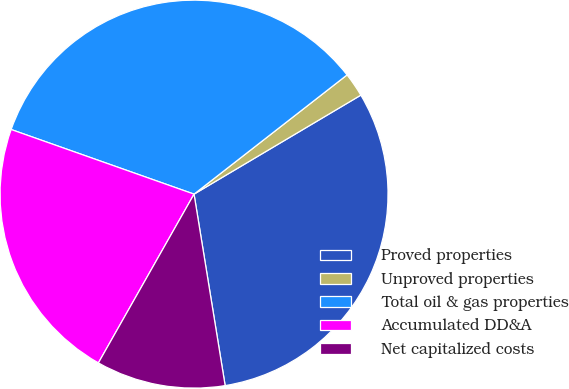Convert chart. <chart><loc_0><loc_0><loc_500><loc_500><pie_chart><fcel>Proved properties<fcel>Unproved properties<fcel>Total oil & gas properties<fcel>Accumulated DD&A<fcel>Net capitalized costs<nl><fcel>30.96%<fcel>2.01%<fcel>34.06%<fcel>22.2%<fcel>10.77%<nl></chart> 